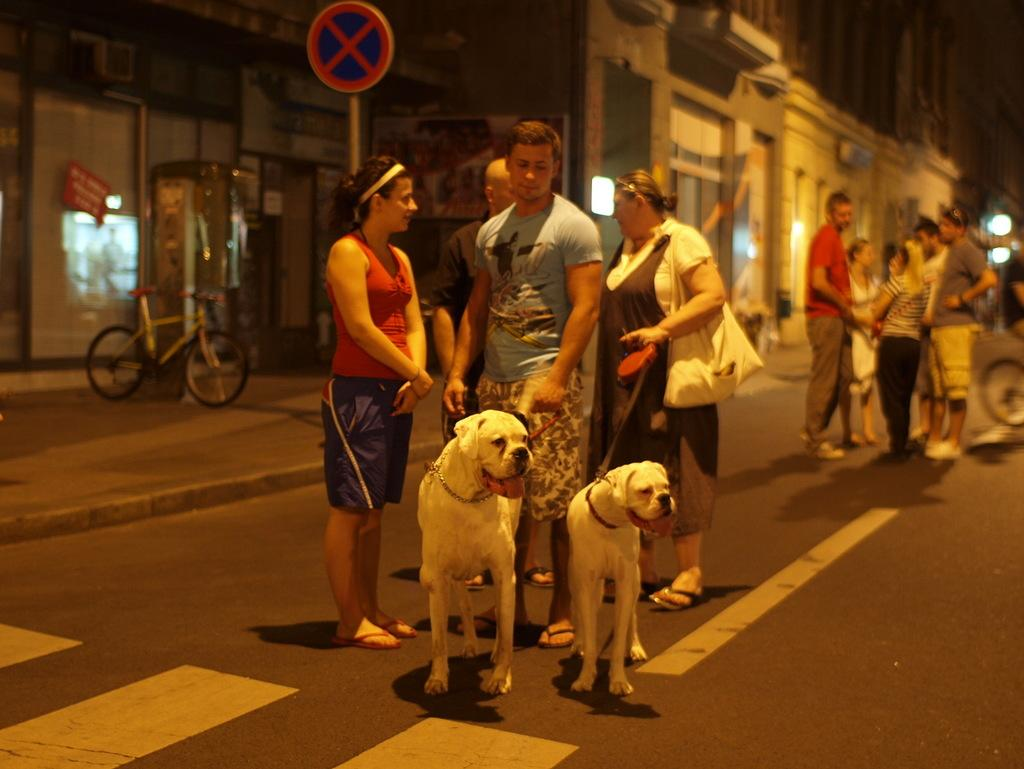What is the person in the image holding? The person is holding two dogs in the image. What can be seen in the background of the image? There are many people standing on the road and a bicycle visible in the background of the image. What type of structures are present in the background of the image? There are buildings in the background of the image. What type of humor can be seen in the image? There is no humor depicted in the image; it shows a person holding two dogs and a background scene. 